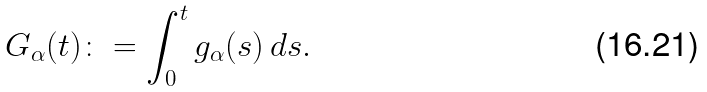<formula> <loc_0><loc_0><loc_500><loc_500>G _ { \alpha } ( t ) \colon = \int _ { 0 } ^ { t } g _ { \alpha } ( s ) \, d s .</formula> 